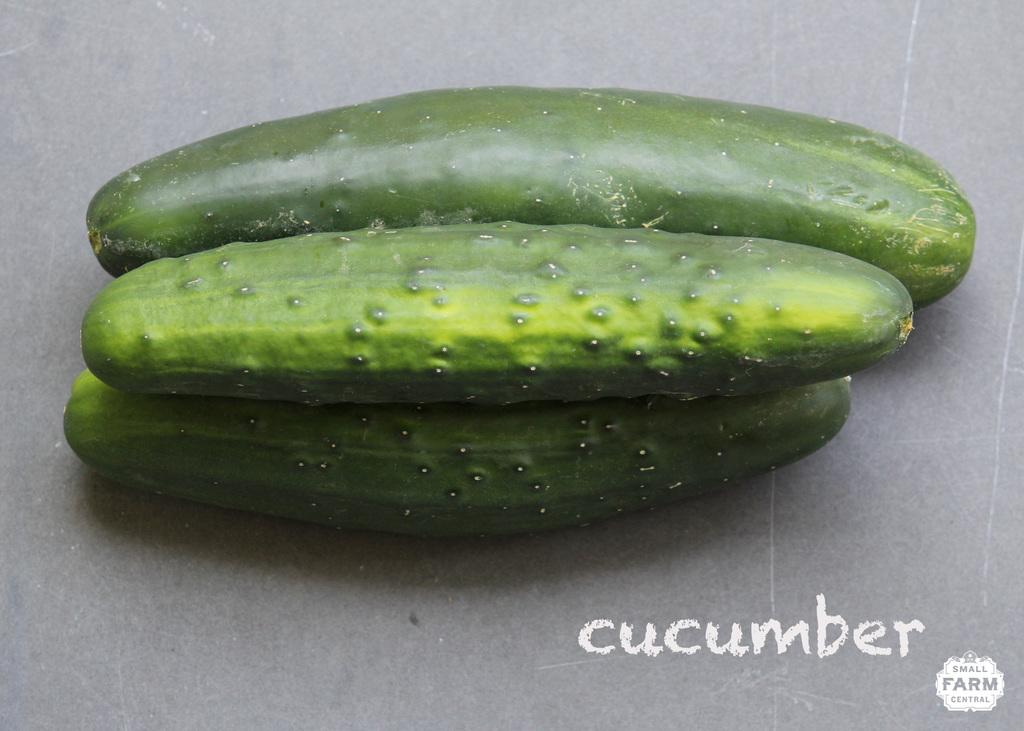How many cucumbers are visible in the image? A: There are three cucumbers in the image. Where are the cucumbers located in the image? The cucumbers are placed on a platform. What type of quill is used to write on the cucumbers in the image? There is no quill or writing present on the cucumbers in the image. 